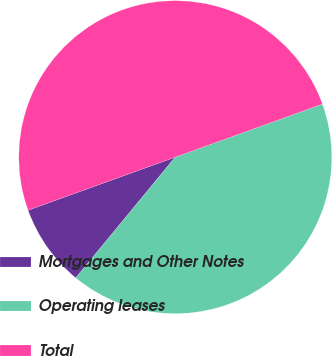<chart> <loc_0><loc_0><loc_500><loc_500><pie_chart><fcel>Mortgages and Other Notes<fcel>Operating leases<fcel>Total<nl><fcel>8.52%<fcel>41.48%<fcel>50.0%<nl></chart> 